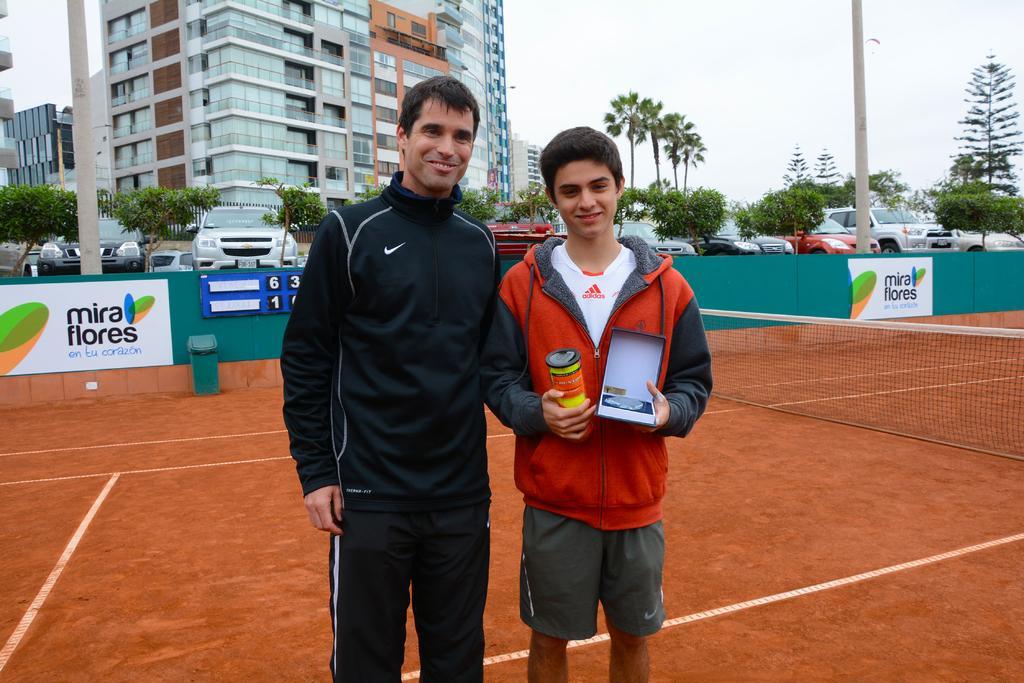In one or two sentences, can you explain what this image depicts? In the center of the image there are two people standing in a tennis court. In the background of the image there are buildings,trees, cars. There are electric poles. There is sky. 